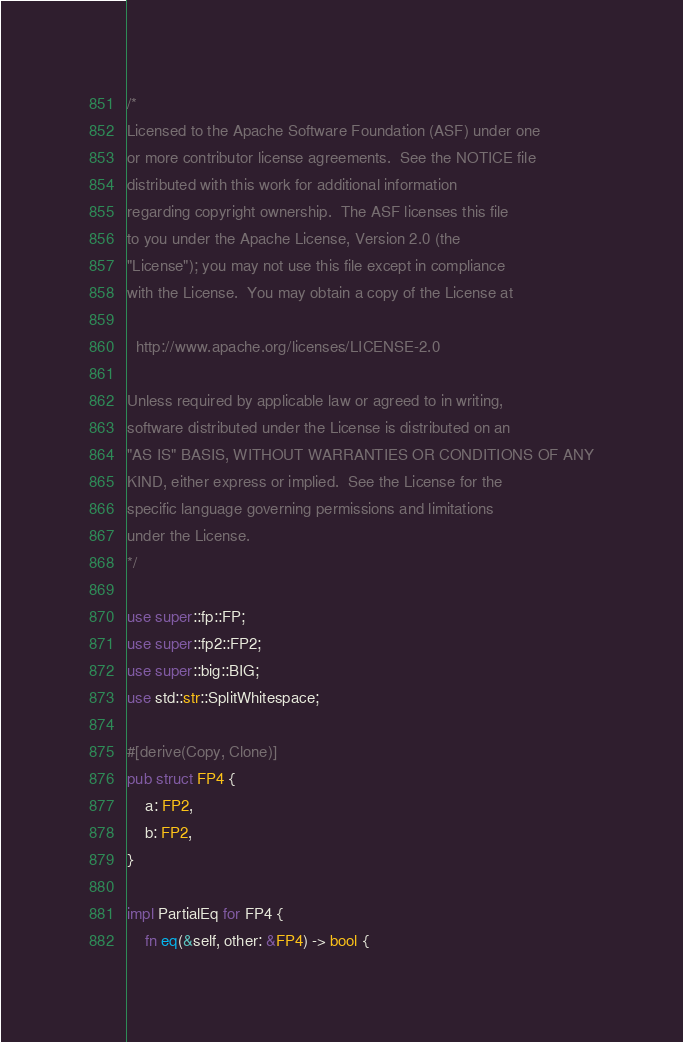Convert code to text. <code><loc_0><loc_0><loc_500><loc_500><_Rust_>/*
Licensed to the Apache Software Foundation (ASF) under one
or more contributor license agreements.  See the NOTICE file
distributed with this work for additional information
regarding copyright ownership.  The ASF licenses this file
to you under the Apache License, Version 2.0 (the
"License"); you may not use this file except in compliance
with the License.  You may obtain a copy of the License at

  http://www.apache.org/licenses/LICENSE-2.0

Unless required by applicable law or agreed to in writing,
software distributed under the License is distributed on an
"AS IS" BASIS, WITHOUT WARRANTIES OR CONDITIONS OF ANY
KIND, either express or implied.  See the License for the
specific language governing permissions and limitations
under the License.
*/

use super::fp::FP;
use super::fp2::FP2;
use super::big::BIG;
use std::str::SplitWhitespace;

#[derive(Copy, Clone)]
pub struct FP4 {
    a: FP2,
    b: FP2,
}

impl PartialEq for FP4 {
	fn eq(&self, other: &FP4) -> bool {</code> 